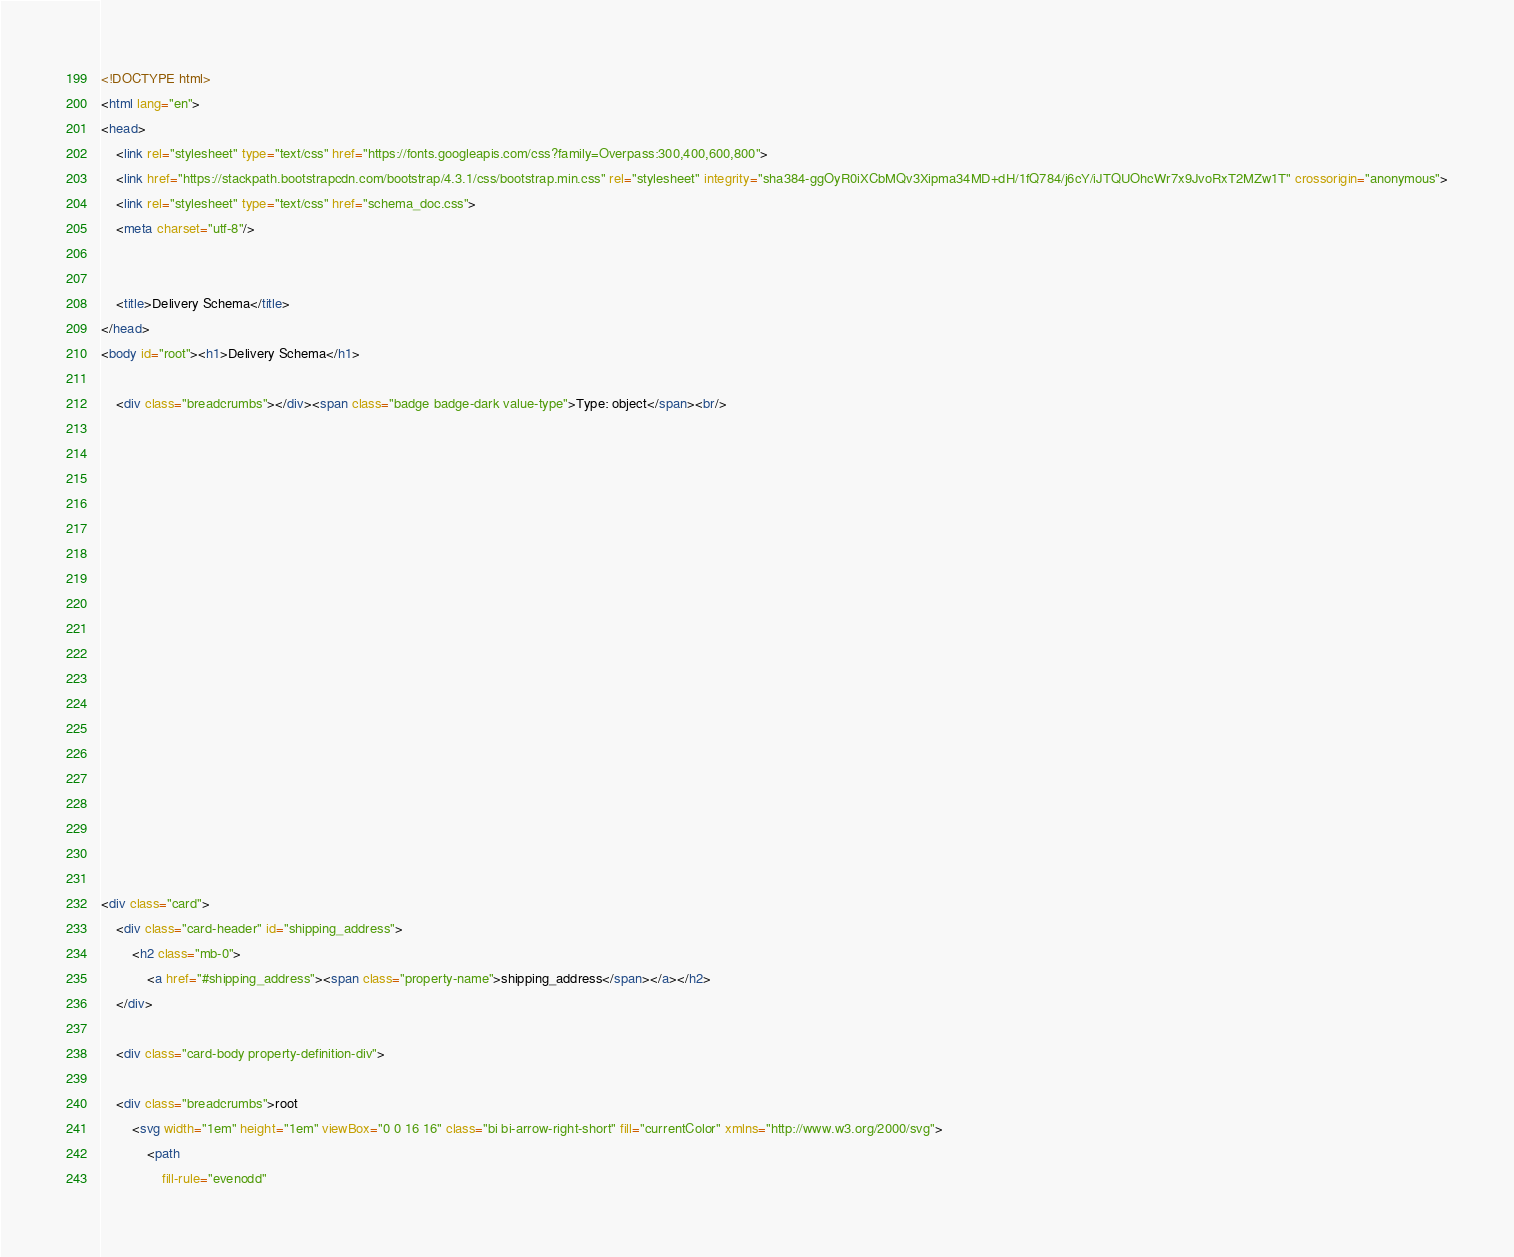Convert code to text. <code><loc_0><loc_0><loc_500><loc_500><_HTML_>

<!DOCTYPE html>
<html lang="en">
<head>
    <link rel="stylesheet" type="text/css" href="https://fonts.googleapis.com/css?family=Overpass:300,400,600,800">
    <link href="https://stackpath.bootstrapcdn.com/bootstrap/4.3.1/css/bootstrap.min.css" rel="stylesheet" integrity="sha384-ggOyR0iXCbMQv3Xipma34MD+dH/1fQ784/j6cY/iJTQUOhcWr7x9JvoRxT2MZw1T" crossorigin="anonymous">
	<link rel="stylesheet" type="text/css" href="schema_doc.css">
    <meta charset="utf-8"/>
        
    
    <title>Delivery Schema</title>
</head>
<body id="root"><h1>Delivery Schema</h1>

    <div class="breadcrumbs"></div><span class="badge badge-dark value-type">Type: object</span><br/>












            

            
            

            

<div class="card">
    <div class="card-header" id="shipping_address">
        <h2 class="mb-0">
            <a href="#shipping_address"><span class="property-name">shipping_address</span></a></h2>
    </div>

    <div class="card-body property-definition-div">

    <div class="breadcrumbs">root
        <svg width="1em" height="1em" viewBox="0 0 16 16" class="bi bi-arrow-right-short" fill="currentColor" xmlns="http://www.w3.org/2000/svg">
            <path
                fill-rule="evenodd"</code> 